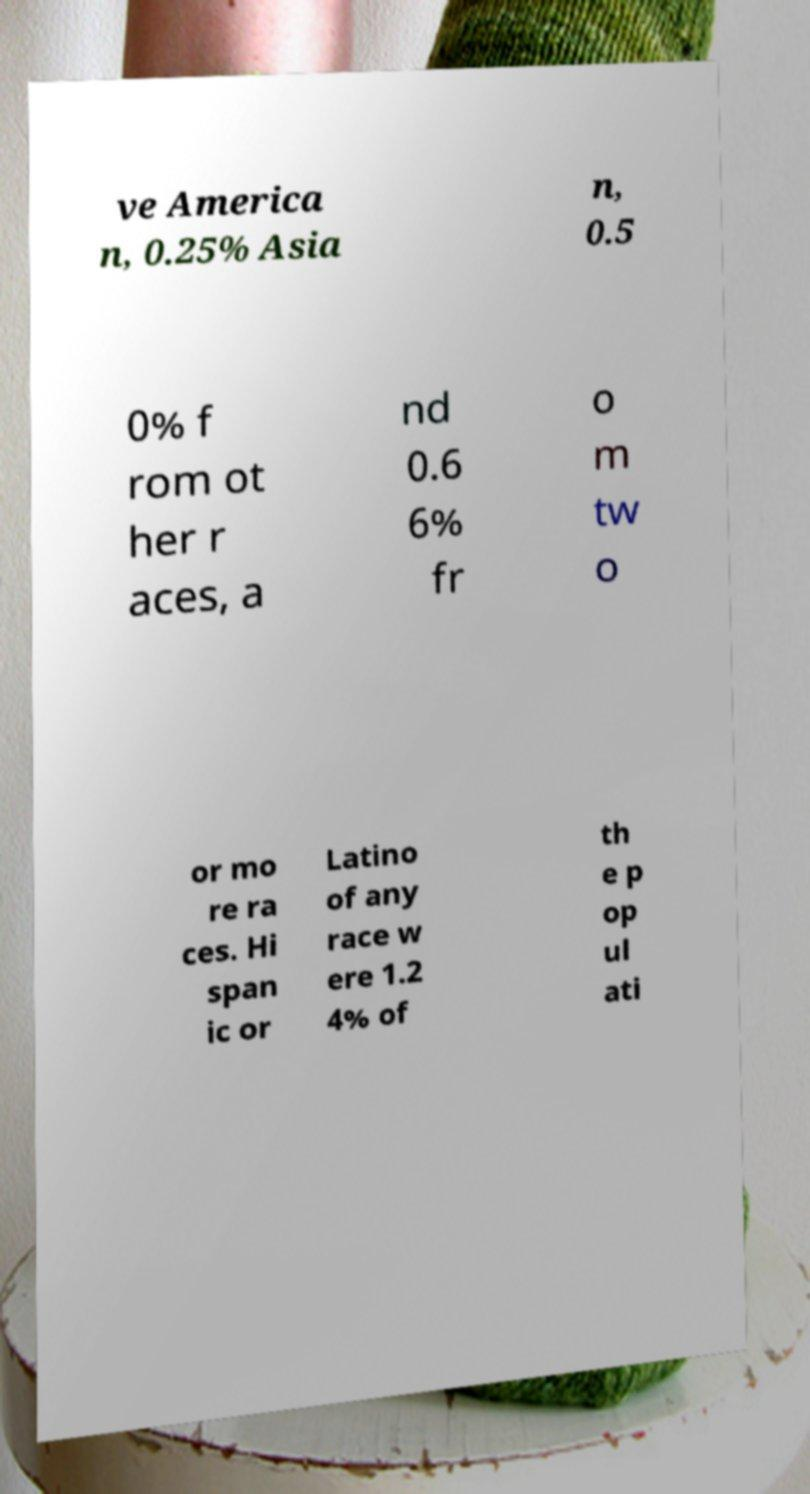What messages or text are displayed in this image? I need them in a readable, typed format. ve America n, 0.25% Asia n, 0.5 0% f rom ot her r aces, a nd 0.6 6% fr o m tw o or mo re ra ces. Hi span ic or Latino of any race w ere 1.2 4% of th e p op ul ati 